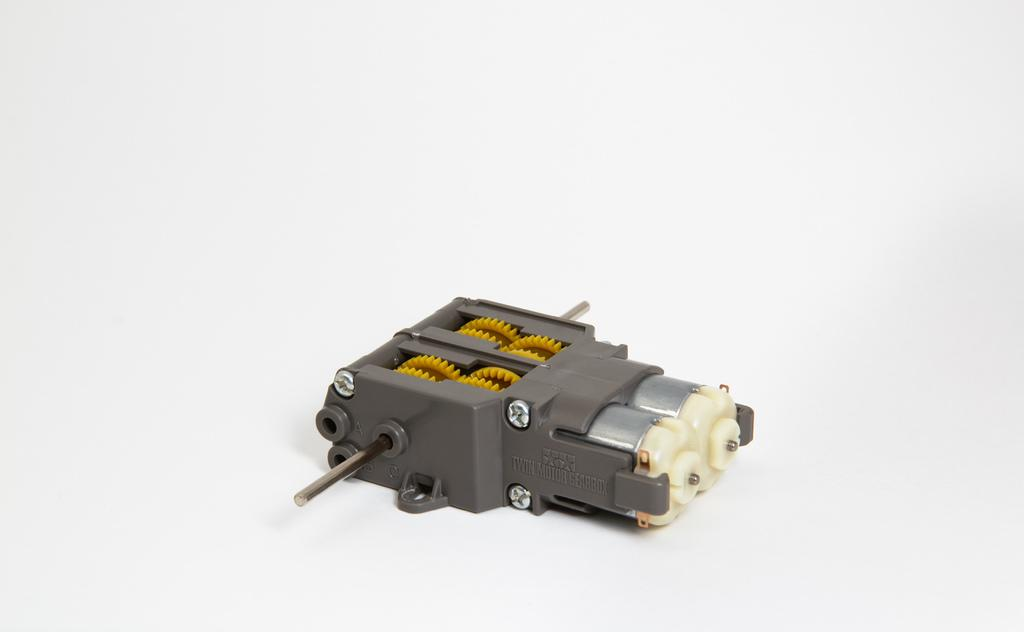What type of toy is in the image? There is a toy motor in the image. What is the color of the surface on which the toy motor is placed? The toy motor is on a white surface. How many chickens are present in the image? There are no chickens present in the image; it only features a toy motor on a white surface. What emotions are being expressed by the toy motor in the image? Toys do not have emotions, so this question cannot be answered. 